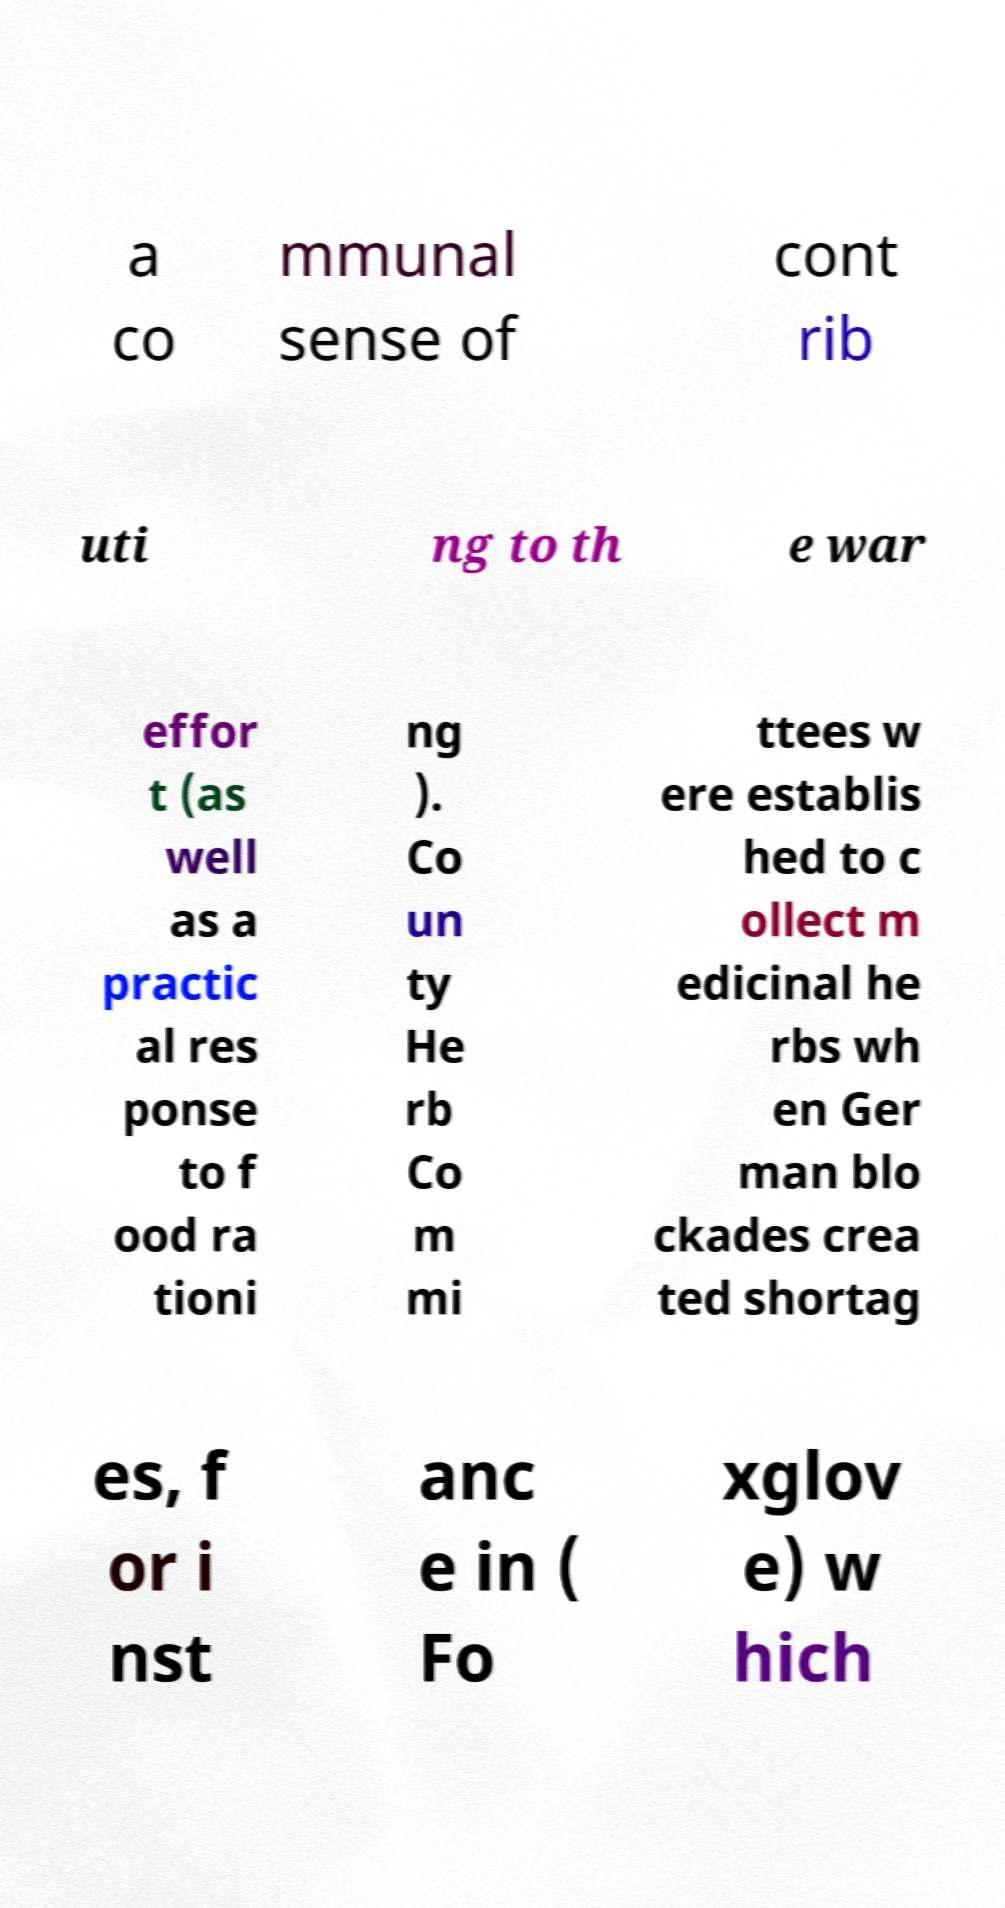Could you extract and type out the text from this image? a co mmunal sense of cont rib uti ng to th e war effor t (as well as a practic al res ponse to f ood ra tioni ng ). Co un ty He rb Co m mi ttees w ere establis hed to c ollect m edicinal he rbs wh en Ger man blo ckades crea ted shortag es, f or i nst anc e in ( Fo xglov e) w hich 